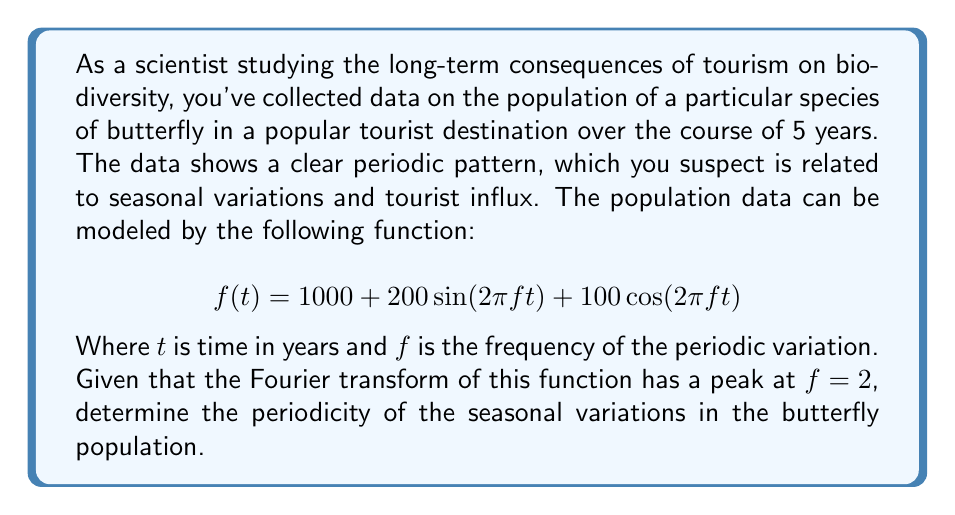Can you answer this question? Let's approach this step-by-step:

1) The given function is in the form of a sinusoidal wave:
   $$f(t) = A + B\sin(2\pi ft) + C\cos(2\pi ft)$$
   Where $A$ is the average population, and $B$ and $C$ determine the amplitude of the variations.

2) The frequency $f$ is given as 2 cycles per year. This means that in one year, the cycle repeats 2 times.

3) To find the period $T$, we use the relationship between frequency and period:
   $$f = \frac{1}{T}$$

4) Rearranging this equation:
   $$T = \frac{1}{f}$$

5) Substituting the given frequency:
   $$T = \frac{1}{2}$$

6) This means the period is 1/2 of a year, or 6 months.

7) In the context of biodiversity and tourism, this suggests that the butterfly population experiences two complete cycles each year, likely corresponding to two tourist seasons (e.g., summer and winter tourism peaks).
Answer: 6 months 